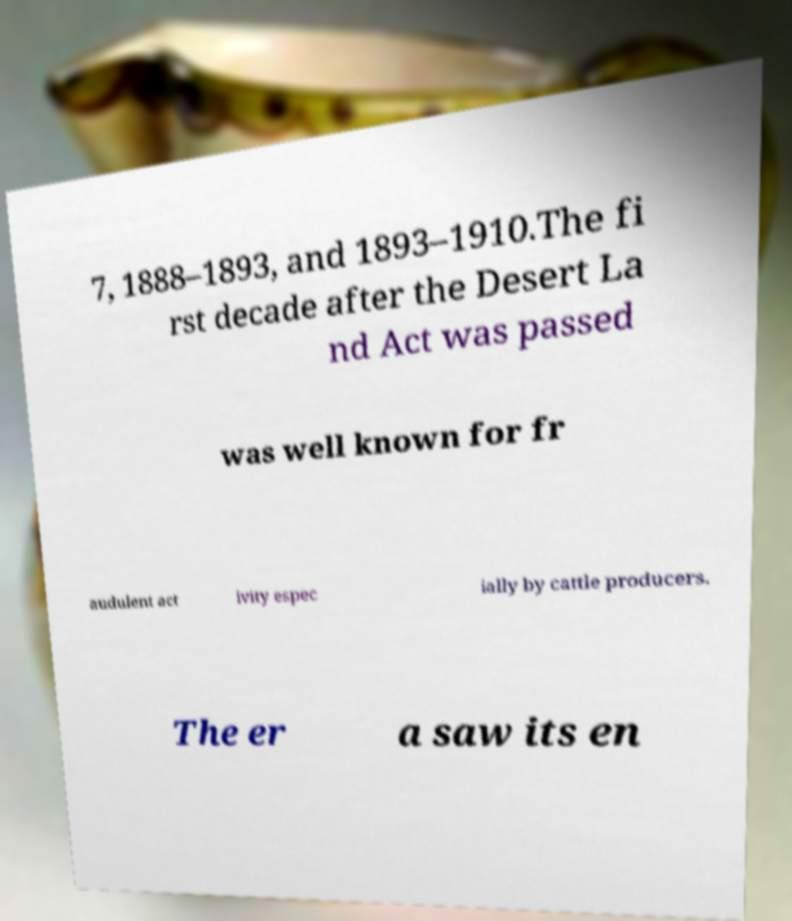Could you assist in decoding the text presented in this image and type it out clearly? 7, 1888–1893, and 1893–1910.The fi rst decade after the Desert La nd Act was passed was well known for fr audulent act ivity espec ially by cattle producers. The er a saw its en 